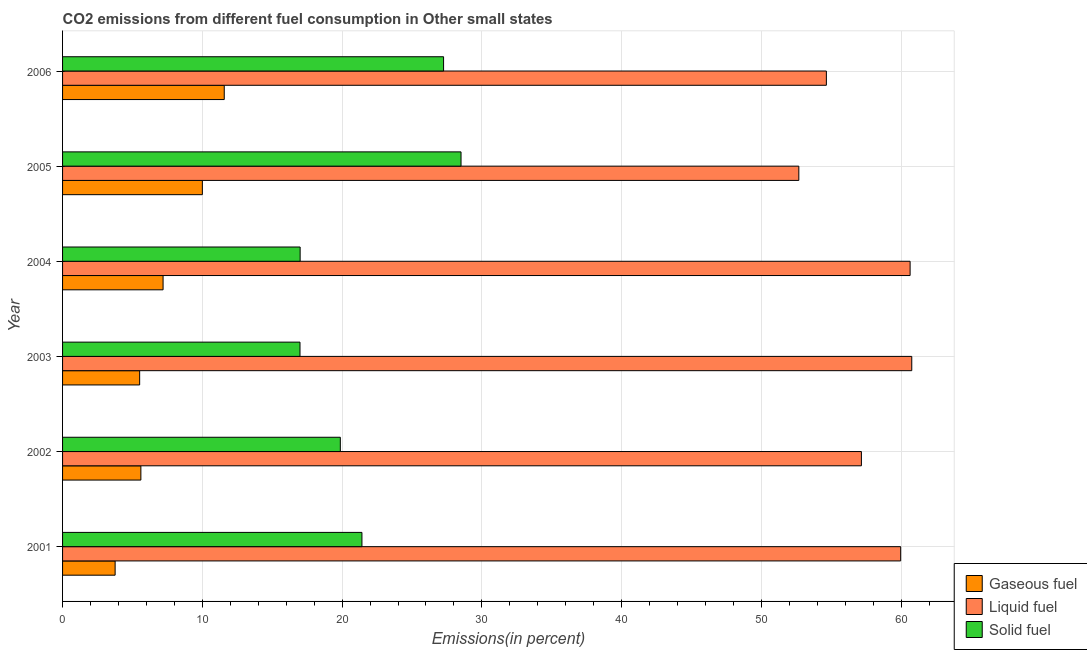How many different coloured bars are there?
Offer a very short reply. 3. How many groups of bars are there?
Ensure brevity in your answer.  6. Are the number of bars per tick equal to the number of legend labels?
Make the answer very short. Yes. How many bars are there on the 1st tick from the bottom?
Provide a succinct answer. 3. What is the percentage of gaseous fuel emission in 2005?
Your response must be concise. 10. Across all years, what is the maximum percentage of gaseous fuel emission?
Your answer should be very brief. 11.57. Across all years, what is the minimum percentage of liquid fuel emission?
Make the answer very short. 52.68. In which year was the percentage of solid fuel emission maximum?
Keep it short and to the point. 2005. In which year was the percentage of liquid fuel emission minimum?
Provide a short and direct response. 2005. What is the total percentage of gaseous fuel emission in the graph?
Provide a succinct answer. 43.64. What is the difference between the percentage of gaseous fuel emission in 2003 and that in 2004?
Your answer should be very brief. -1.68. What is the difference between the percentage of liquid fuel emission in 2002 and the percentage of solid fuel emission in 2004?
Ensure brevity in your answer.  40.16. What is the average percentage of gaseous fuel emission per year?
Make the answer very short. 7.27. In the year 2006, what is the difference between the percentage of solid fuel emission and percentage of liquid fuel emission?
Offer a very short reply. -27.39. In how many years, is the percentage of solid fuel emission greater than 18 %?
Make the answer very short. 4. What is the ratio of the percentage of liquid fuel emission in 2002 to that in 2003?
Provide a short and direct response. 0.94. Is the percentage of liquid fuel emission in 2003 less than that in 2004?
Your answer should be very brief. No. Is the difference between the percentage of gaseous fuel emission in 2001 and 2006 greater than the difference between the percentage of solid fuel emission in 2001 and 2006?
Give a very brief answer. No. What is the difference between the highest and the second highest percentage of gaseous fuel emission?
Offer a very short reply. 1.57. What is the difference between the highest and the lowest percentage of liquid fuel emission?
Make the answer very short. 8.08. What does the 1st bar from the top in 2003 represents?
Ensure brevity in your answer.  Solid fuel. What does the 2nd bar from the bottom in 2003 represents?
Offer a very short reply. Liquid fuel. Is it the case that in every year, the sum of the percentage of gaseous fuel emission and percentage of liquid fuel emission is greater than the percentage of solid fuel emission?
Provide a succinct answer. Yes. How many bars are there?
Offer a very short reply. 18. How many years are there in the graph?
Keep it short and to the point. 6. Does the graph contain any zero values?
Provide a short and direct response. No. Where does the legend appear in the graph?
Your answer should be compact. Bottom right. How many legend labels are there?
Keep it short and to the point. 3. How are the legend labels stacked?
Provide a succinct answer. Vertical. What is the title of the graph?
Make the answer very short. CO2 emissions from different fuel consumption in Other small states. Does "Renewable sources" appear as one of the legend labels in the graph?
Give a very brief answer. No. What is the label or title of the X-axis?
Give a very brief answer. Emissions(in percent). What is the label or title of the Y-axis?
Provide a succinct answer. Year. What is the Emissions(in percent) in Gaseous fuel in 2001?
Ensure brevity in your answer.  3.76. What is the Emissions(in percent) of Liquid fuel in 2001?
Make the answer very short. 59.96. What is the Emissions(in percent) of Solid fuel in 2001?
Your response must be concise. 21.42. What is the Emissions(in percent) of Gaseous fuel in 2002?
Your answer should be compact. 5.6. What is the Emissions(in percent) in Liquid fuel in 2002?
Provide a succinct answer. 57.15. What is the Emissions(in percent) in Solid fuel in 2002?
Make the answer very short. 19.87. What is the Emissions(in percent) in Gaseous fuel in 2003?
Provide a succinct answer. 5.52. What is the Emissions(in percent) of Liquid fuel in 2003?
Your response must be concise. 60.76. What is the Emissions(in percent) in Solid fuel in 2003?
Make the answer very short. 16.99. What is the Emissions(in percent) of Gaseous fuel in 2004?
Your answer should be very brief. 7.19. What is the Emissions(in percent) in Liquid fuel in 2004?
Ensure brevity in your answer.  60.64. What is the Emissions(in percent) in Solid fuel in 2004?
Provide a succinct answer. 17. What is the Emissions(in percent) in Gaseous fuel in 2005?
Ensure brevity in your answer.  10. What is the Emissions(in percent) of Liquid fuel in 2005?
Provide a succinct answer. 52.68. What is the Emissions(in percent) in Solid fuel in 2005?
Your response must be concise. 28.51. What is the Emissions(in percent) in Gaseous fuel in 2006?
Ensure brevity in your answer.  11.57. What is the Emissions(in percent) of Liquid fuel in 2006?
Your answer should be very brief. 54.65. What is the Emissions(in percent) of Solid fuel in 2006?
Keep it short and to the point. 27.26. Across all years, what is the maximum Emissions(in percent) in Gaseous fuel?
Ensure brevity in your answer.  11.57. Across all years, what is the maximum Emissions(in percent) in Liquid fuel?
Ensure brevity in your answer.  60.76. Across all years, what is the maximum Emissions(in percent) in Solid fuel?
Your answer should be very brief. 28.51. Across all years, what is the minimum Emissions(in percent) of Gaseous fuel?
Offer a very short reply. 3.76. Across all years, what is the minimum Emissions(in percent) in Liquid fuel?
Provide a succinct answer. 52.68. Across all years, what is the minimum Emissions(in percent) of Solid fuel?
Give a very brief answer. 16.99. What is the total Emissions(in percent) in Gaseous fuel in the graph?
Offer a very short reply. 43.64. What is the total Emissions(in percent) of Liquid fuel in the graph?
Give a very brief answer. 345.83. What is the total Emissions(in percent) in Solid fuel in the graph?
Provide a succinct answer. 131.04. What is the difference between the Emissions(in percent) in Gaseous fuel in 2001 and that in 2002?
Ensure brevity in your answer.  -1.84. What is the difference between the Emissions(in percent) in Liquid fuel in 2001 and that in 2002?
Your response must be concise. 2.81. What is the difference between the Emissions(in percent) in Solid fuel in 2001 and that in 2002?
Give a very brief answer. 1.55. What is the difference between the Emissions(in percent) of Gaseous fuel in 2001 and that in 2003?
Your response must be concise. -1.75. What is the difference between the Emissions(in percent) of Liquid fuel in 2001 and that in 2003?
Provide a succinct answer. -0.79. What is the difference between the Emissions(in percent) in Solid fuel in 2001 and that in 2003?
Ensure brevity in your answer.  4.43. What is the difference between the Emissions(in percent) of Gaseous fuel in 2001 and that in 2004?
Your answer should be very brief. -3.43. What is the difference between the Emissions(in percent) in Liquid fuel in 2001 and that in 2004?
Keep it short and to the point. -0.68. What is the difference between the Emissions(in percent) of Solid fuel in 2001 and that in 2004?
Keep it short and to the point. 4.42. What is the difference between the Emissions(in percent) of Gaseous fuel in 2001 and that in 2005?
Offer a very short reply. -6.24. What is the difference between the Emissions(in percent) of Liquid fuel in 2001 and that in 2005?
Keep it short and to the point. 7.29. What is the difference between the Emissions(in percent) of Solid fuel in 2001 and that in 2005?
Ensure brevity in your answer.  -7.09. What is the difference between the Emissions(in percent) of Gaseous fuel in 2001 and that in 2006?
Your response must be concise. -7.81. What is the difference between the Emissions(in percent) in Liquid fuel in 2001 and that in 2006?
Provide a short and direct response. 5.32. What is the difference between the Emissions(in percent) in Solid fuel in 2001 and that in 2006?
Ensure brevity in your answer.  -5.84. What is the difference between the Emissions(in percent) in Gaseous fuel in 2002 and that in 2003?
Provide a short and direct response. 0.09. What is the difference between the Emissions(in percent) of Liquid fuel in 2002 and that in 2003?
Make the answer very short. -3.6. What is the difference between the Emissions(in percent) of Solid fuel in 2002 and that in 2003?
Your answer should be very brief. 2.88. What is the difference between the Emissions(in percent) of Gaseous fuel in 2002 and that in 2004?
Keep it short and to the point. -1.59. What is the difference between the Emissions(in percent) of Liquid fuel in 2002 and that in 2004?
Provide a short and direct response. -3.49. What is the difference between the Emissions(in percent) in Solid fuel in 2002 and that in 2004?
Ensure brevity in your answer.  2.88. What is the difference between the Emissions(in percent) in Gaseous fuel in 2002 and that in 2005?
Your answer should be compact. -4.4. What is the difference between the Emissions(in percent) of Liquid fuel in 2002 and that in 2005?
Your answer should be very brief. 4.48. What is the difference between the Emissions(in percent) of Solid fuel in 2002 and that in 2005?
Offer a very short reply. -8.64. What is the difference between the Emissions(in percent) of Gaseous fuel in 2002 and that in 2006?
Make the answer very short. -5.97. What is the difference between the Emissions(in percent) of Liquid fuel in 2002 and that in 2006?
Your answer should be compact. 2.51. What is the difference between the Emissions(in percent) in Solid fuel in 2002 and that in 2006?
Your response must be concise. -7.39. What is the difference between the Emissions(in percent) in Gaseous fuel in 2003 and that in 2004?
Make the answer very short. -1.68. What is the difference between the Emissions(in percent) of Liquid fuel in 2003 and that in 2004?
Provide a short and direct response. 0.12. What is the difference between the Emissions(in percent) of Solid fuel in 2003 and that in 2004?
Your answer should be compact. -0.01. What is the difference between the Emissions(in percent) of Gaseous fuel in 2003 and that in 2005?
Your answer should be very brief. -4.49. What is the difference between the Emissions(in percent) in Liquid fuel in 2003 and that in 2005?
Your answer should be very brief. 8.08. What is the difference between the Emissions(in percent) of Solid fuel in 2003 and that in 2005?
Give a very brief answer. -11.52. What is the difference between the Emissions(in percent) of Gaseous fuel in 2003 and that in 2006?
Provide a succinct answer. -6.05. What is the difference between the Emissions(in percent) of Liquid fuel in 2003 and that in 2006?
Offer a very short reply. 6.11. What is the difference between the Emissions(in percent) in Solid fuel in 2003 and that in 2006?
Offer a terse response. -10.27. What is the difference between the Emissions(in percent) in Gaseous fuel in 2004 and that in 2005?
Your answer should be compact. -2.81. What is the difference between the Emissions(in percent) of Liquid fuel in 2004 and that in 2005?
Offer a very short reply. 7.96. What is the difference between the Emissions(in percent) of Solid fuel in 2004 and that in 2005?
Offer a very short reply. -11.51. What is the difference between the Emissions(in percent) of Gaseous fuel in 2004 and that in 2006?
Ensure brevity in your answer.  -4.38. What is the difference between the Emissions(in percent) of Liquid fuel in 2004 and that in 2006?
Offer a very short reply. 5.99. What is the difference between the Emissions(in percent) in Solid fuel in 2004 and that in 2006?
Make the answer very short. -10.26. What is the difference between the Emissions(in percent) in Gaseous fuel in 2005 and that in 2006?
Provide a short and direct response. -1.57. What is the difference between the Emissions(in percent) in Liquid fuel in 2005 and that in 2006?
Make the answer very short. -1.97. What is the difference between the Emissions(in percent) in Solid fuel in 2005 and that in 2006?
Provide a succinct answer. 1.25. What is the difference between the Emissions(in percent) of Gaseous fuel in 2001 and the Emissions(in percent) of Liquid fuel in 2002?
Provide a short and direct response. -53.39. What is the difference between the Emissions(in percent) of Gaseous fuel in 2001 and the Emissions(in percent) of Solid fuel in 2002?
Make the answer very short. -16.11. What is the difference between the Emissions(in percent) in Liquid fuel in 2001 and the Emissions(in percent) in Solid fuel in 2002?
Give a very brief answer. 40.09. What is the difference between the Emissions(in percent) in Gaseous fuel in 2001 and the Emissions(in percent) in Liquid fuel in 2003?
Your response must be concise. -57. What is the difference between the Emissions(in percent) in Gaseous fuel in 2001 and the Emissions(in percent) in Solid fuel in 2003?
Provide a short and direct response. -13.23. What is the difference between the Emissions(in percent) of Liquid fuel in 2001 and the Emissions(in percent) of Solid fuel in 2003?
Offer a terse response. 42.98. What is the difference between the Emissions(in percent) in Gaseous fuel in 2001 and the Emissions(in percent) in Liquid fuel in 2004?
Offer a very short reply. -56.88. What is the difference between the Emissions(in percent) in Gaseous fuel in 2001 and the Emissions(in percent) in Solid fuel in 2004?
Your answer should be compact. -13.24. What is the difference between the Emissions(in percent) in Liquid fuel in 2001 and the Emissions(in percent) in Solid fuel in 2004?
Your answer should be compact. 42.97. What is the difference between the Emissions(in percent) in Gaseous fuel in 2001 and the Emissions(in percent) in Liquid fuel in 2005?
Provide a succinct answer. -48.92. What is the difference between the Emissions(in percent) of Gaseous fuel in 2001 and the Emissions(in percent) of Solid fuel in 2005?
Ensure brevity in your answer.  -24.75. What is the difference between the Emissions(in percent) in Liquid fuel in 2001 and the Emissions(in percent) in Solid fuel in 2005?
Your answer should be compact. 31.45. What is the difference between the Emissions(in percent) of Gaseous fuel in 2001 and the Emissions(in percent) of Liquid fuel in 2006?
Give a very brief answer. -50.89. What is the difference between the Emissions(in percent) in Gaseous fuel in 2001 and the Emissions(in percent) in Solid fuel in 2006?
Offer a terse response. -23.5. What is the difference between the Emissions(in percent) in Liquid fuel in 2001 and the Emissions(in percent) in Solid fuel in 2006?
Provide a short and direct response. 32.7. What is the difference between the Emissions(in percent) of Gaseous fuel in 2002 and the Emissions(in percent) of Liquid fuel in 2003?
Keep it short and to the point. -55.15. What is the difference between the Emissions(in percent) of Gaseous fuel in 2002 and the Emissions(in percent) of Solid fuel in 2003?
Your answer should be very brief. -11.39. What is the difference between the Emissions(in percent) of Liquid fuel in 2002 and the Emissions(in percent) of Solid fuel in 2003?
Your answer should be very brief. 40.17. What is the difference between the Emissions(in percent) of Gaseous fuel in 2002 and the Emissions(in percent) of Liquid fuel in 2004?
Offer a terse response. -55.04. What is the difference between the Emissions(in percent) in Gaseous fuel in 2002 and the Emissions(in percent) in Solid fuel in 2004?
Provide a short and direct response. -11.39. What is the difference between the Emissions(in percent) in Liquid fuel in 2002 and the Emissions(in percent) in Solid fuel in 2004?
Your answer should be compact. 40.16. What is the difference between the Emissions(in percent) in Gaseous fuel in 2002 and the Emissions(in percent) in Liquid fuel in 2005?
Your answer should be compact. -47.07. What is the difference between the Emissions(in percent) of Gaseous fuel in 2002 and the Emissions(in percent) of Solid fuel in 2005?
Offer a very short reply. -22.91. What is the difference between the Emissions(in percent) of Liquid fuel in 2002 and the Emissions(in percent) of Solid fuel in 2005?
Ensure brevity in your answer.  28.64. What is the difference between the Emissions(in percent) of Gaseous fuel in 2002 and the Emissions(in percent) of Liquid fuel in 2006?
Ensure brevity in your answer.  -49.04. What is the difference between the Emissions(in percent) of Gaseous fuel in 2002 and the Emissions(in percent) of Solid fuel in 2006?
Your answer should be compact. -21.66. What is the difference between the Emissions(in percent) in Liquid fuel in 2002 and the Emissions(in percent) in Solid fuel in 2006?
Keep it short and to the point. 29.89. What is the difference between the Emissions(in percent) in Gaseous fuel in 2003 and the Emissions(in percent) in Liquid fuel in 2004?
Provide a short and direct response. -55.12. What is the difference between the Emissions(in percent) in Gaseous fuel in 2003 and the Emissions(in percent) in Solid fuel in 2004?
Make the answer very short. -11.48. What is the difference between the Emissions(in percent) in Liquid fuel in 2003 and the Emissions(in percent) in Solid fuel in 2004?
Provide a succinct answer. 43.76. What is the difference between the Emissions(in percent) of Gaseous fuel in 2003 and the Emissions(in percent) of Liquid fuel in 2005?
Your answer should be very brief. -47.16. What is the difference between the Emissions(in percent) in Gaseous fuel in 2003 and the Emissions(in percent) in Solid fuel in 2005?
Your answer should be very brief. -22.99. What is the difference between the Emissions(in percent) of Liquid fuel in 2003 and the Emissions(in percent) of Solid fuel in 2005?
Provide a succinct answer. 32.25. What is the difference between the Emissions(in percent) of Gaseous fuel in 2003 and the Emissions(in percent) of Liquid fuel in 2006?
Keep it short and to the point. -49.13. What is the difference between the Emissions(in percent) of Gaseous fuel in 2003 and the Emissions(in percent) of Solid fuel in 2006?
Offer a terse response. -21.74. What is the difference between the Emissions(in percent) of Liquid fuel in 2003 and the Emissions(in percent) of Solid fuel in 2006?
Your answer should be very brief. 33.5. What is the difference between the Emissions(in percent) of Gaseous fuel in 2004 and the Emissions(in percent) of Liquid fuel in 2005?
Give a very brief answer. -45.48. What is the difference between the Emissions(in percent) in Gaseous fuel in 2004 and the Emissions(in percent) in Solid fuel in 2005?
Ensure brevity in your answer.  -21.32. What is the difference between the Emissions(in percent) of Liquid fuel in 2004 and the Emissions(in percent) of Solid fuel in 2005?
Your answer should be very brief. 32.13. What is the difference between the Emissions(in percent) in Gaseous fuel in 2004 and the Emissions(in percent) in Liquid fuel in 2006?
Your answer should be compact. -47.46. What is the difference between the Emissions(in percent) in Gaseous fuel in 2004 and the Emissions(in percent) in Solid fuel in 2006?
Ensure brevity in your answer.  -20.07. What is the difference between the Emissions(in percent) of Liquid fuel in 2004 and the Emissions(in percent) of Solid fuel in 2006?
Your response must be concise. 33.38. What is the difference between the Emissions(in percent) of Gaseous fuel in 2005 and the Emissions(in percent) of Liquid fuel in 2006?
Make the answer very short. -44.65. What is the difference between the Emissions(in percent) in Gaseous fuel in 2005 and the Emissions(in percent) in Solid fuel in 2006?
Provide a short and direct response. -17.26. What is the difference between the Emissions(in percent) in Liquid fuel in 2005 and the Emissions(in percent) in Solid fuel in 2006?
Your answer should be compact. 25.42. What is the average Emissions(in percent) in Gaseous fuel per year?
Your response must be concise. 7.27. What is the average Emissions(in percent) in Liquid fuel per year?
Keep it short and to the point. 57.64. What is the average Emissions(in percent) of Solid fuel per year?
Provide a short and direct response. 21.84. In the year 2001, what is the difference between the Emissions(in percent) in Gaseous fuel and Emissions(in percent) in Liquid fuel?
Provide a succinct answer. -56.2. In the year 2001, what is the difference between the Emissions(in percent) in Gaseous fuel and Emissions(in percent) in Solid fuel?
Provide a short and direct response. -17.66. In the year 2001, what is the difference between the Emissions(in percent) of Liquid fuel and Emissions(in percent) of Solid fuel?
Your answer should be compact. 38.54. In the year 2002, what is the difference between the Emissions(in percent) in Gaseous fuel and Emissions(in percent) in Liquid fuel?
Offer a very short reply. -51.55. In the year 2002, what is the difference between the Emissions(in percent) of Gaseous fuel and Emissions(in percent) of Solid fuel?
Provide a short and direct response. -14.27. In the year 2002, what is the difference between the Emissions(in percent) of Liquid fuel and Emissions(in percent) of Solid fuel?
Your answer should be very brief. 37.28. In the year 2003, what is the difference between the Emissions(in percent) in Gaseous fuel and Emissions(in percent) in Liquid fuel?
Offer a very short reply. -55.24. In the year 2003, what is the difference between the Emissions(in percent) of Gaseous fuel and Emissions(in percent) of Solid fuel?
Keep it short and to the point. -11.47. In the year 2003, what is the difference between the Emissions(in percent) in Liquid fuel and Emissions(in percent) in Solid fuel?
Ensure brevity in your answer.  43.77. In the year 2004, what is the difference between the Emissions(in percent) of Gaseous fuel and Emissions(in percent) of Liquid fuel?
Offer a very short reply. -53.45. In the year 2004, what is the difference between the Emissions(in percent) of Gaseous fuel and Emissions(in percent) of Solid fuel?
Give a very brief answer. -9.81. In the year 2004, what is the difference between the Emissions(in percent) in Liquid fuel and Emissions(in percent) in Solid fuel?
Your response must be concise. 43.64. In the year 2005, what is the difference between the Emissions(in percent) in Gaseous fuel and Emissions(in percent) in Liquid fuel?
Your answer should be very brief. -42.67. In the year 2005, what is the difference between the Emissions(in percent) of Gaseous fuel and Emissions(in percent) of Solid fuel?
Your answer should be compact. -18.51. In the year 2005, what is the difference between the Emissions(in percent) of Liquid fuel and Emissions(in percent) of Solid fuel?
Your response must be concise. 24.17. In the year 2006, what is the difference between the Emissions(in percent) of Gaseous fuel and Emissions(in percent) of Liquid fuel?
Your response must be concise. -43.08. In the year 2006, what is the difference between the Emissions(in percent) in Gaseous fuel and Emissions(in percent) in Solid fuel?
Make the answer very short. -15.69. In the year 2006, what is the difference between the Emissions(in percent) of Liquid fuel and Emissions(in percent) of Solid fuel?
Offer a very short reply. 27.39. What is the ratio of the Emissions(in percent) in Gaseous fuel in 2001 to that in 2002?
Offer a very short reply. 0.67. What is the ratio of the Emissions(in percent) of Liquid fuel in 2001 to that in 2002?
Provide a succinct answer. 1.05. What is the ratio of the Emissions(in percent) in Solid fuel in 2001 to that in 2002?
Give a very brief answer. 1.08. What is the ratio of the Emissions(in percent) in Gaseous fuel in 2001 to that in 2003?
Give a very brief answer. 0.68. What is the ratio of the Emissions(in percent) in Liquid fuel in 2001 to that in 2003?
Provide a succinct answer. 0.99. What is the ratio of the Emissions(in percent) in Solid fuel in 2001 to that in 2003?
Your answer should be very brief. 1.26. What is the ratio of the Emissions(in percent) in Gaseous fuel in 2001 to that in 2004?
Offer a very short reply. 0.52. What is the ratio of the Emissions(in percent) of Liquid fuel in 2001 to that in 2004?
Provide a succinct answer. 0.99. What is the ratio of the Emissions(in percent) of Solid fuel in 2001 to that in 2004?
Provide a short and direct response. 1.26. What is the ratio of the Emissions(in percent) of Gaseous fuel in 2001 to that in 2005?
Provide a succinct answer. 0.38. What is the ratio of the Emissions(in percent) of Liquid fuel in 2001 to that in 2005?
Your answer should be compact. 1.14. What is the ratio of the Emissions(in percent) in Solid fuel in 2001 to that in 2005?
Ensure brevity in your answer.  0.75. What is the ratio of the Emissions(in percent) in Gaseous fuel in 2001 to that in 2006?
Provide a succinct answer. 0.33. What is the ratio of the Emissions(in percent) of Liquid fuel in 2001 to that in 2006?
Make the answer very short. 1.1. What is the ratio of the Emissions(in percent) of Solid fuel in 2001 to that in 2006?
Make the answer very short. 0.79. What is the ratio of the Emissions(in percent) of Gaseous fuel in 2002 to that in 2003?
Ensure brevity in your answer.  1.02. What is the ratio of the Emissions(in percent) of Liquid fuel in 2002 to that in 2003?
Ensure brevity in your answer.  0.94. What is the ratio of the Emissions(in percent) of Solid fuel in 2002 to that in 2003?
Your answer should be compact. 1.17. What is the ratio of the Emissions(in percent) in Gaseous fuel in 2002 to that in 2004?
Offer a very short reply. 0.78. What is the ratio of the Emissions(in percent) of Liquid fuel in 2002 to that in 2004?
Offer a very short reply. 0.94. What is the ratio of the Emissions(in percent) of Solid fuel in 2002 to that in 2004?
Make the answer very short. 1.17. What is the ratio of the Emissions(in percent) in Gaseous fuel in 2002 to that in 2005?
Give a very brief answer. 0.56. What is the ratio of the Emissions(in percent) in Liquid fuel in 2002 to that in 2005?
Your answer should be very brief. 1.08. What is the ratio of the Emissions(in percent) in Solid fuel in 2002 to that in 2005?
Offer a terse response. 0.7. What is the ratio of the Emissions(in percent) of Gaseous fuel in 2002 to that in 2006?
Your answer should be compact. 0.48. What is the ratio of the Emissions(in percent) of Liquid fuel in 2002 to that in 2006?
Offer a very short reply. 1.05. What is the ratio of the Emissions(in percent) of Solid fuel in 2002 to that in 2006?
Your response must be concise. 0.73. What is the ratio of the Emissions(in percent) of Gaseous fuel in 2003 to that in 2004?
Offer a very short reply. 0.77. What is the ratio of the Emissions(in percent) in Liquid fuel in 2003 to that in 2004?
Your response must be concise. 1. What is the ratio of the Emissions(in percent) in Gaseous fuel in 2003 to that in 2005?
Provide a succinct answer. 0.55. What is the ratio of the Emissions(in percent) in Liquid fuel in 2003 to that in 2005?
Offer a terse response. 1.15. What is the ratio of the Emissions(in percent) in Solid fuel in 2003 to that in 2005?
Provide a short and direct response. 0.6. What is the ratio of the Emissions(in percent) in Gaseous fuel in 2003 to that in 2006?
Keep it short and to the point. 0.48. What is the ratio of the Emissions(in percent) of Liquid fuel in 2003 to that in 2006?
Make the answer very short. 1.11. What is the ratio of the Emissions(in percent) of Solid fuel in 2003 to that in 2006?
Keep it short and to the point. 0.62. What is the ratio of the Emissions(in percent) of Gaseous fuel in 2004 to that in 2005?
Offer a very short reply. 0.72. What is the ratio of the Emissions(in percent) in Liquid fuel in 2004 to that in 2005?
Make the answer very short. 1.15. What is the ratio of the Emissions(in percent) in Solid fuel in 2004 to that in 2005?
Ensure brevity in your answer.  0.6. What is the ratio of the Emissions(in percent) in Gaseous fuel in 2004 to that in 2006?
Give a very brief answer. 0.62. What is the ratio of the Emissions(in percent) of Liquid fuel in 2004 to that in 2006?
Ensure brevity in your answer.  1.11. What is the ratio of the Emissions(in percent) of Solid fuel in 2004 to that in 2006?
Provide a succinct answer. 0.62. What is the ratio of the Emissions(in percent) in Gaseous fuel in 2005 to that in 2006?
Give a very brief answer. 0.86. What is the ratio of the Emissions(in percent) in Liquid fuel in 2005 to that in 2006?
Your response must be concise. 0.96. What is the ratio of the Emissions(in percent) of Solid fuel in 2005 to that in 2006?
Your answer should be very brief. 1.05. What is the difference between the highest and the second highest Emissions(in percent) in Gaseous fuel?
Keep it short and to the point. 1.57. What is the difference between the highest and the second highest Emissions(in percent) of Liquid fuel?
Keep it short and to the point. 0.12. What is the difference between the highest and the second highest Emissions(in percent) of Solid fuel?
Make the answer very short. 1.25. What is the difference between the highest and the lowest Emissions(in percent) of Gaseous fuel?
Provide a short and direct response. 7.81. What is the difference between the highest and the lowest Emissions(in percent) in Liquid fuel?
Offer a terse response. 8.08. What is the difference between the highest and the lowest Emissions(in percent) of Solid fuel?
Ensure brevity in your answer.  11.52. 